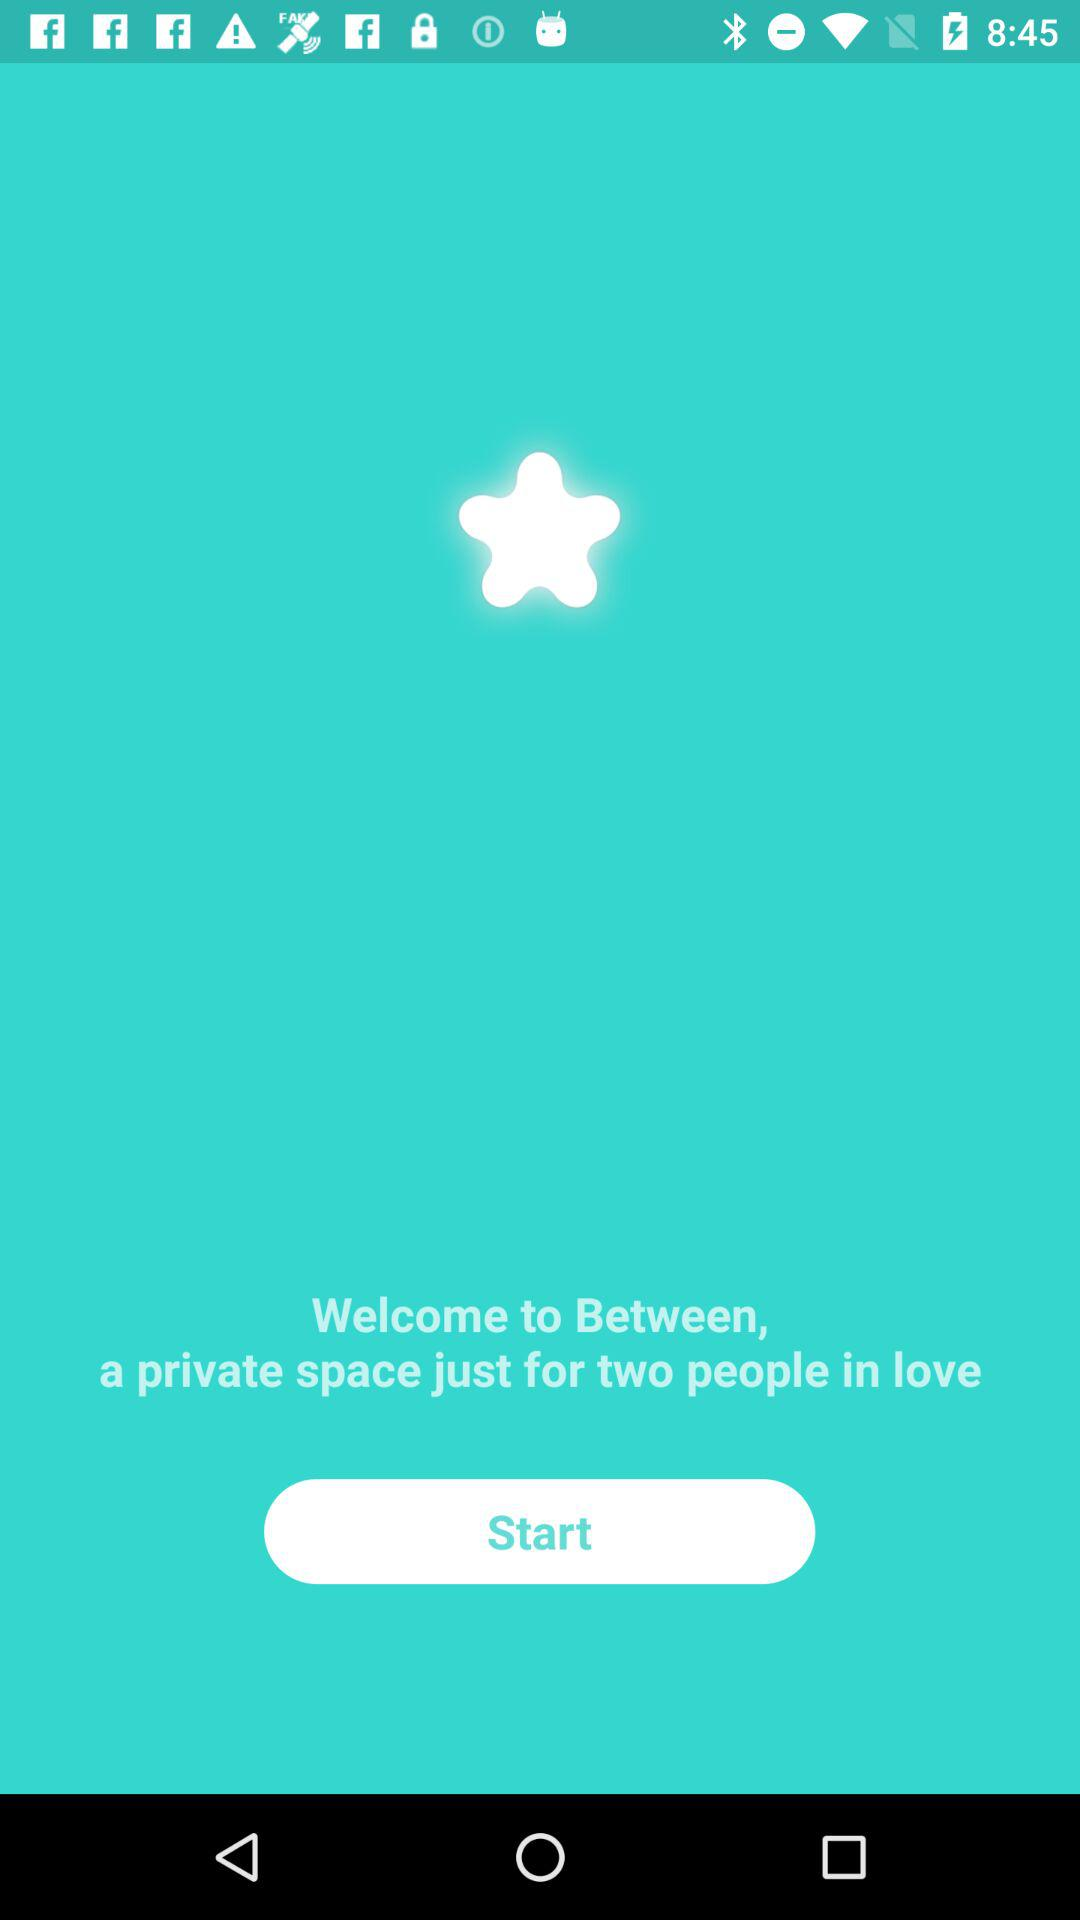What is the application name? The application name is "Between". 